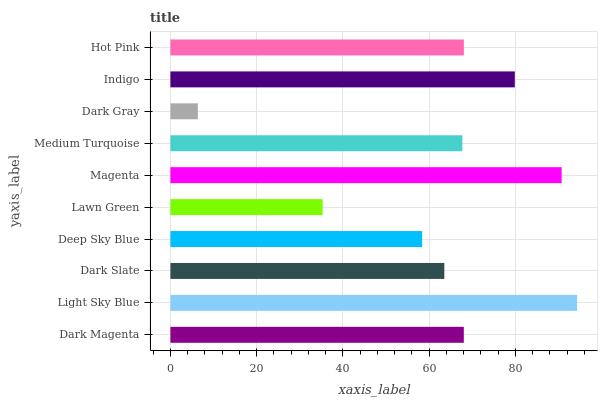Is Dark Gray the minimum?
Answer yes or no. Yes. Is Light Sky Blue the maximum?
Answer yes or no. Yes. Is Dark Slate the minimum?
Answer yes or no. No. Is Dark Slate the maximum?
Answer yes or no. No. Is Light Sky Blue greater than Dark Slate?
Answer yes or no. Yes. Is Dark Slate less than Light Sky Blue?
Answer yes or no. Yes. Is Dark Slate greater than Light Sky Blue?
Answer yes or no. No. Is Light Sky Blue less than Dark Slate?
Answer yes or no. No. Is Dark Magenta the high median?
Answer yes or no. Yes. Is Medium Turquoise the low median?
Answer yes or no. Yes. Is Magenta the high median?
Answer yes or no. No. Is Dark Gray the low median?
Answer yes or no. No. 